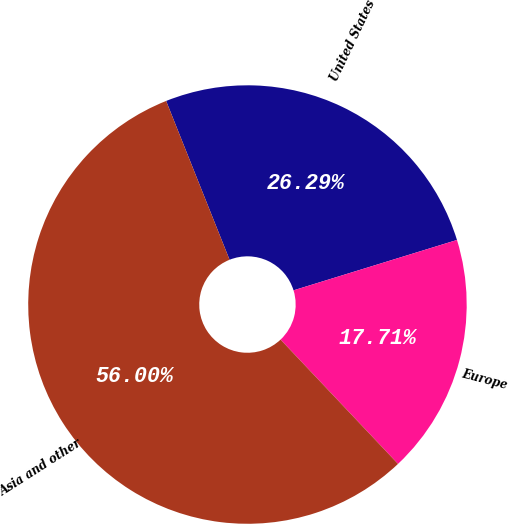Convert chart to OTSL. <chart><loc_0><loc_0><loc_500><loc_500><pie_chart><fcel>United States<fcel>Europe<fcel>Asia and other<nl><fcel>26.29%<fcel>17.71%<fcel>56.0%<nl></chart> 